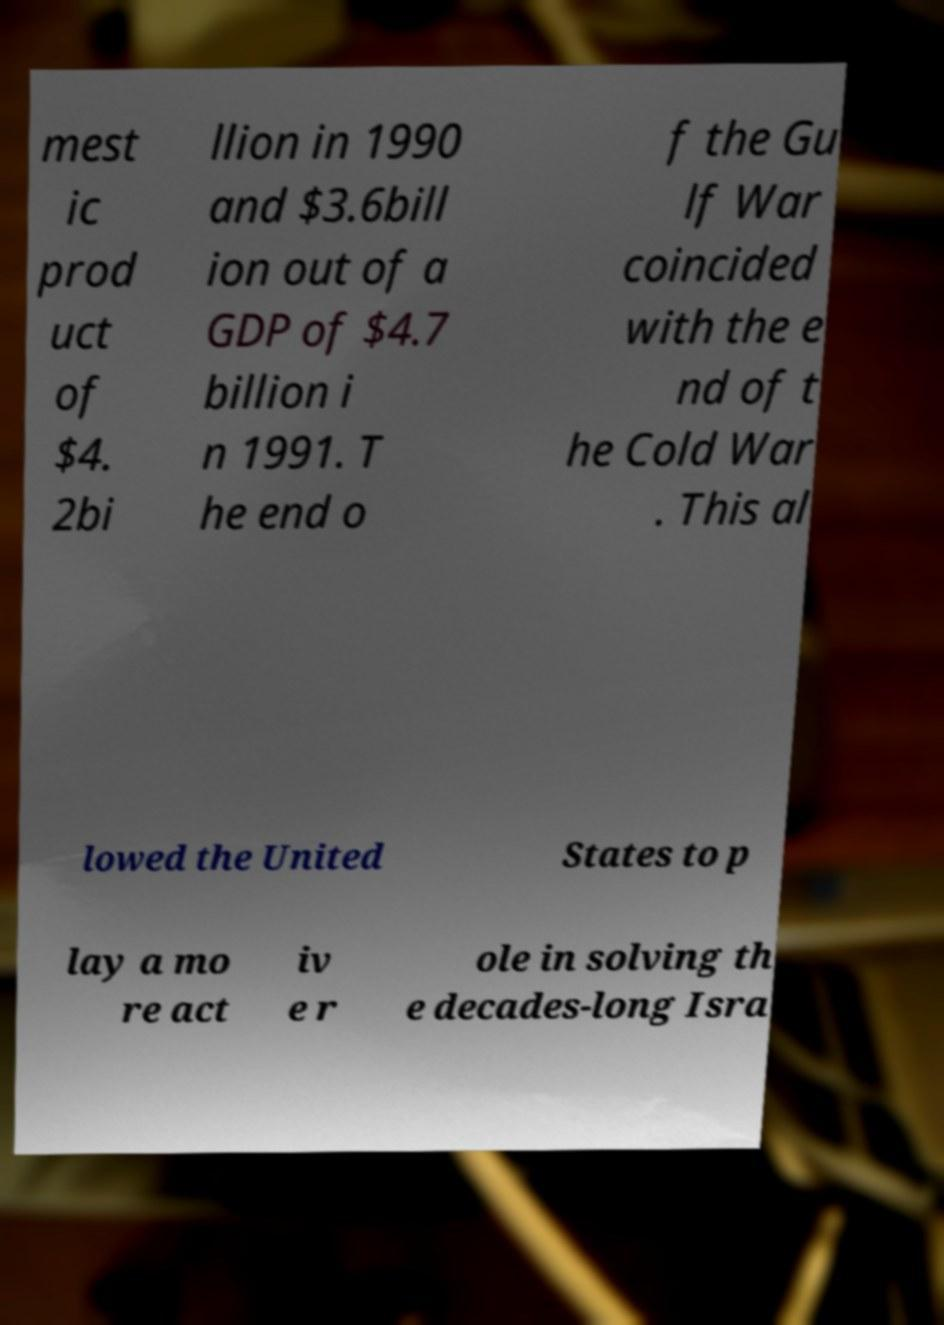There's text embedded in this image that I need extracted. Can you transcribe it verbatim? mest ic prod uct of $4. 2bi llion in 1990 and $3.6bill ion out of a GDP of $4.7 billion i n 1991. T he end o f the Gu lf War coincided with the e nd of t he Cold War . This al lowed the United States to p lay a mo re act iv e r ole in solving th e decades-long Isra 